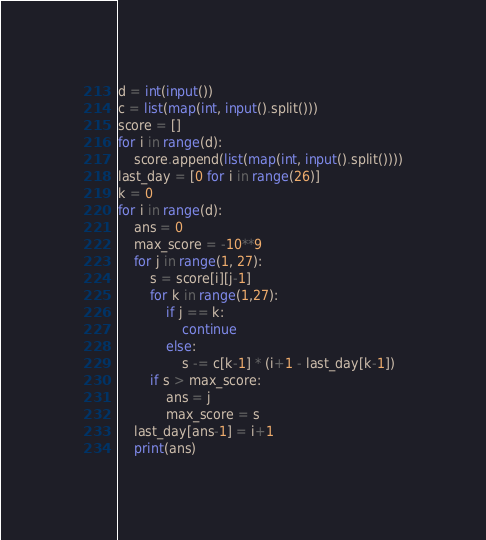<code> <loc_0><loc_0><loc_500><loc_500><_Python_>d = int(input())
c = list(map(int, input().split()))
score = []
for i in range(d):
    score.append(list(map(int, input().split())))
last_day = [0 for i in range(26)]
k = 0
for i in range(d):
    ans = 0
    max_score = -10**9
    for j in range(1, 27):
        s = score[i][j-1]
        for k in range(1,27):
            if j == k:
                continue
            else:
                s -= c[k-1] * (i+1 - last_day[k-1])
        if s > max_score:
            ans = j
            max_score = s
    last_day[ans-1] = i+1
    print(ans)</code> 